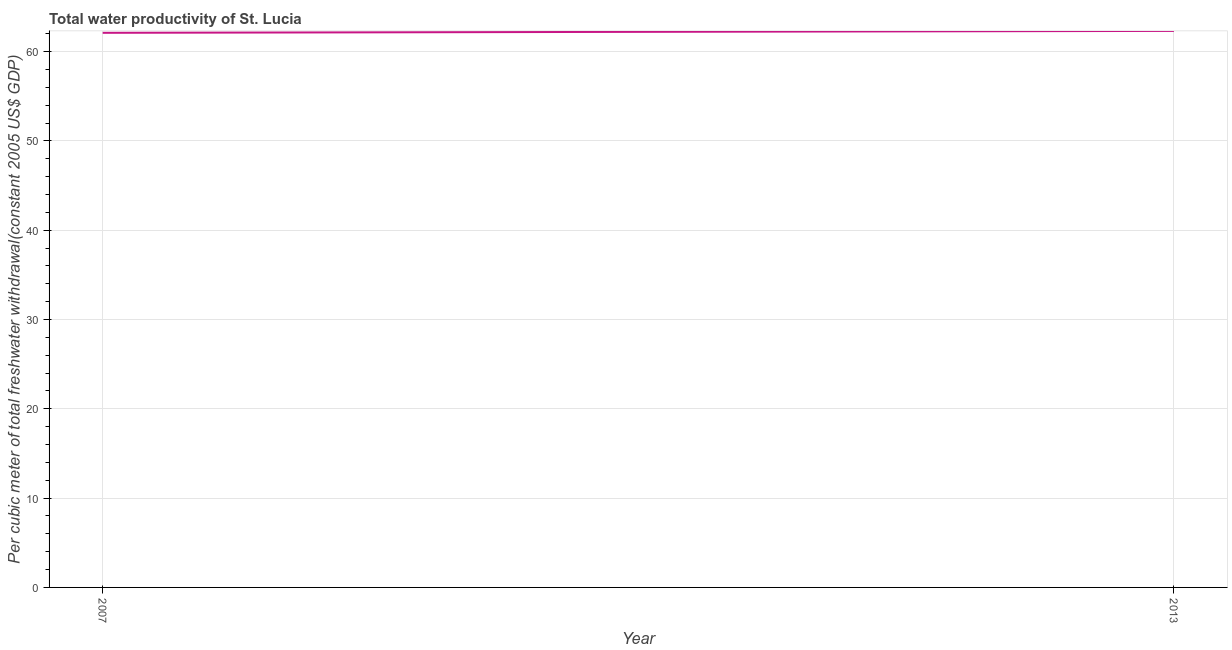What is the total water productivity in 2007?
Your response must be concise. 62.1. Across all years, what is the maximum total water productivity?
Your answer should be compact. 62.32. Across all years, what is the minimum total water productivity?
Ensure brevity in your answer.  62.1. In which year was the total water productivity maximum?
Your answer should be compact. 2013. What is the sum of the total water productivity?
Your response must be concise. 124.42. What is the difference between the total water productivity in 2007 and 2013?
Ensure brevity in your answer.  -0.21. What is the average total water productivity per year?
Give a very brief answer. 62.21. What is the median total water productivity?
Your response must be concise. 62.21. In how many years, is the total water productivity greater than 58 US$?
Offer a terse response. 2. What is the ratio of the total water productivity in 2007 to that in 2013?
Ensure brevity in your answer.  1. How many years are there in the graph?
Offer a very short reply. 2. What is the difference between two consecutive major ticks on the Y-axis?
Give a very brief answer. 10. Does the graph contain grids?
Offer a terse response. Yes. What is the title of the graph?
Provide a short and direct response. Total water productivity of St. Lucia. What is the label or title of the X-axis?
Provide a short and direct response. Year. What is the label or title of the Y-axis?
Keep it short and to the point. Per cubic meter of total freshwater withdrawal(constant 2005 US$ GDP). What is the Per cubic meter of total freshwater withdrawal(constant 2005 US$ GDP) of 2007?
Provide a short and direct response. 62.1. What is the Per cubic meter of total freshwater withdrawal(constant 2005 US$ GDP) of 2013?
Offer a very short reply. 62.32. What is the difference between the Per cubic meter of total freshwater withdrawal(constant 2005 US$ GDP) in 2007 and 2013?
Your response must be concise. -0.21. 